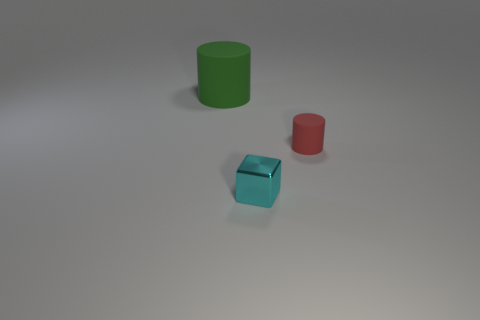Add 3 red shiny cylinders. How many objects exist? 6 Subtract all cubes. How many objects are left? 2 Add 2 cyan blocks. How many cyan blocks are left? 3 Add 1 large blue shiny spheres. How many large blue shiny spheres exist? 1 Subtract 0 red balls. How many objects are left? 3 Subtract all tiny matte cylinders. Subtract all large green matte objects. How many objects are left? 1 